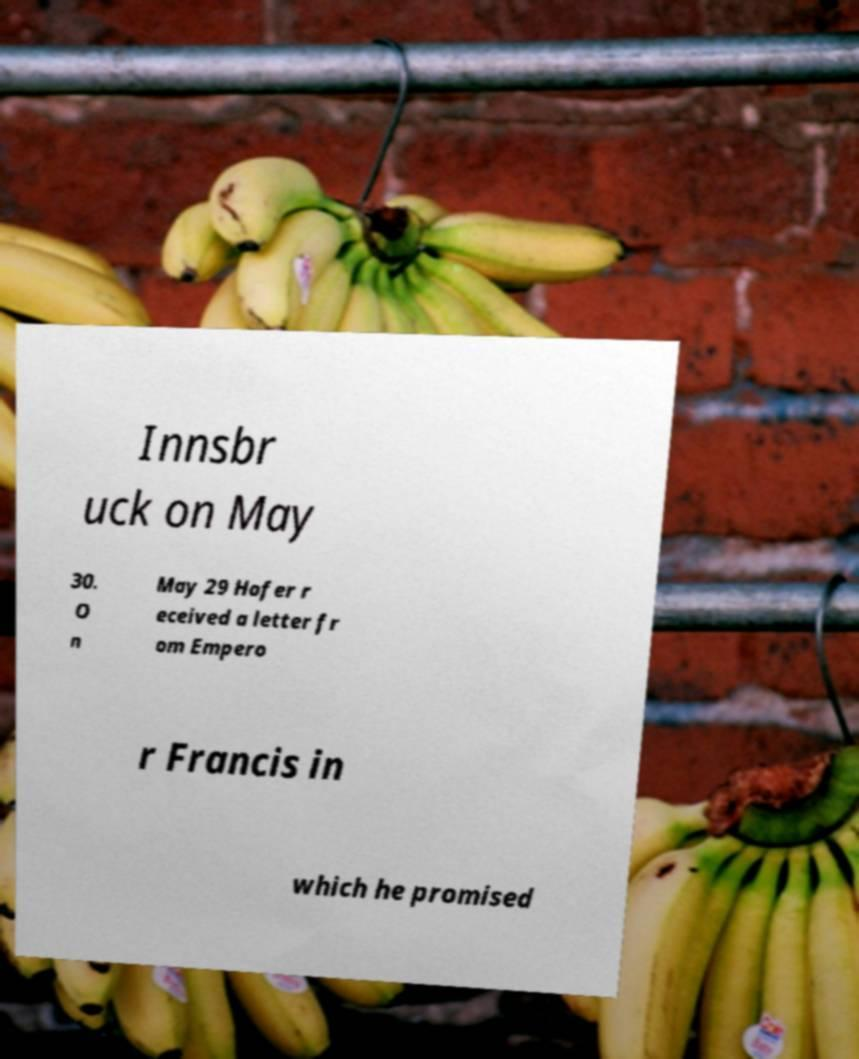What messages or text are displayed in this image? I need them in a readable, typed format. Innsbr uck on May 30. O n May 29 Hofer r eceived a letter fr om Empero r Francis in which he promised 